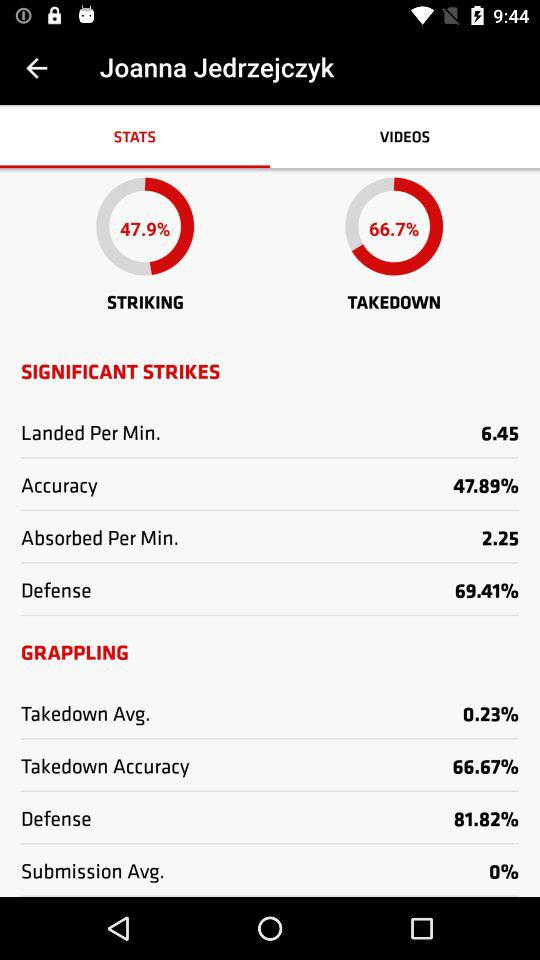What is the absorbed per minute? The absorbed per minute is 2.25. 